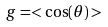Convert formula to latex. <formula><loc_0><loc_0><loc_500><loc_500>g = < \cos ( \theta ) ></formula> 